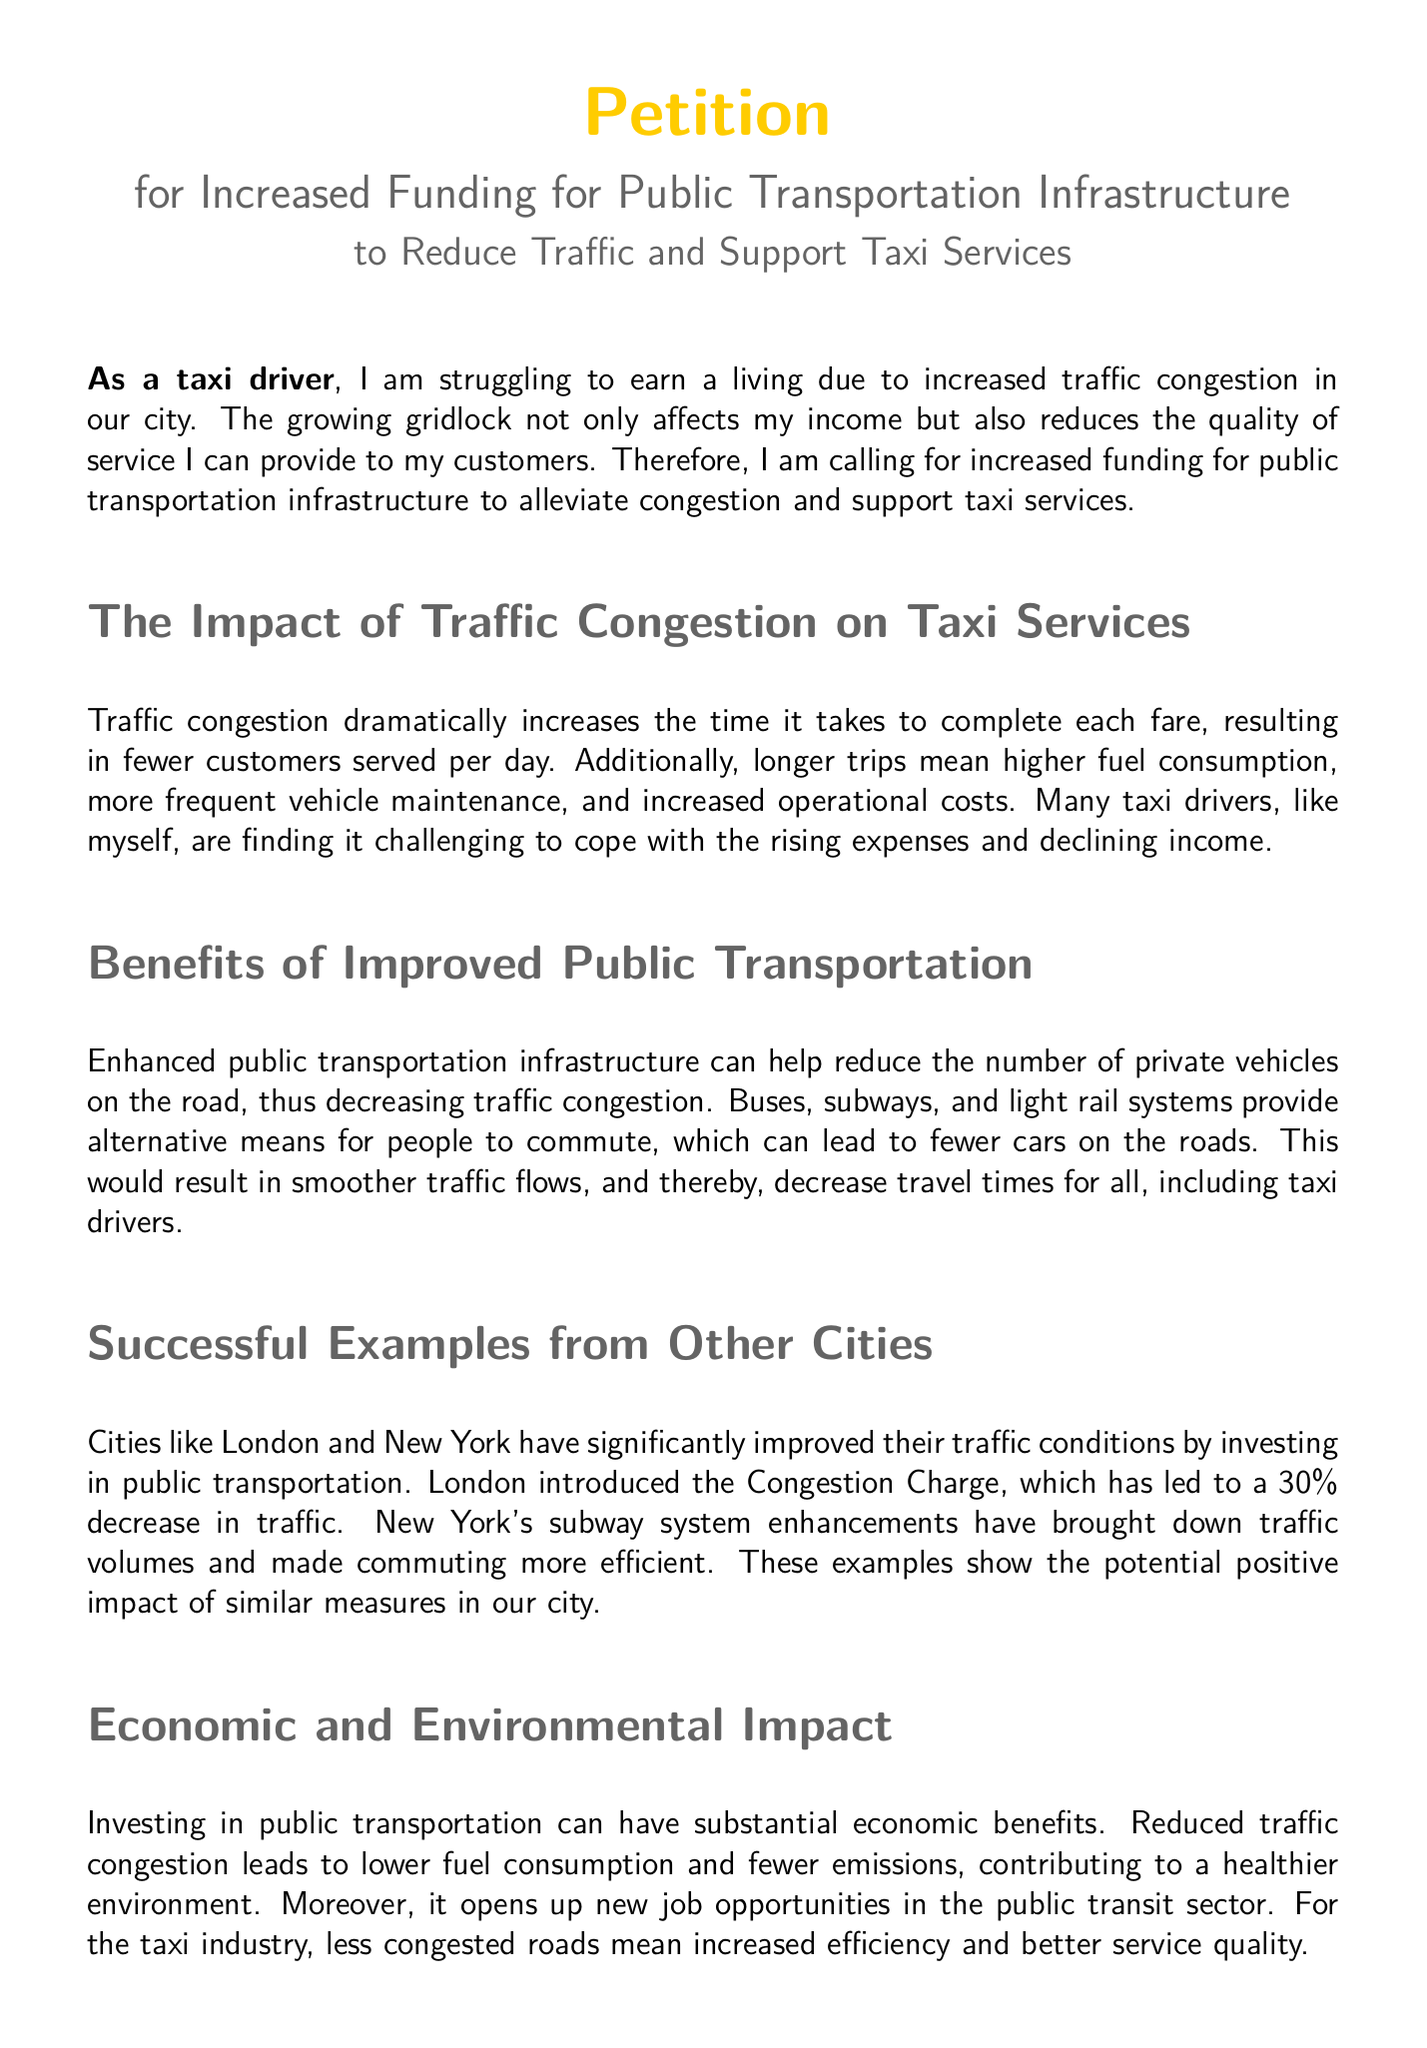What is the main purpose of the petition? The main purpose is to call for increased funding for public transportation infrastructure to alleviate congestion and support taxi services.
Answer: Increased funding for public transportation infrastructure How does traffic congestion affect taxi drivers? Traffic congestion increases the time it takes to complete each fare, resulting in fewer customers served per day and higher operational costs.
Answer: It increases fare time and operational costs What percentage decrease in traffic did London's Congestion Charge achieve? The document states that London's Congestion Charge led to a 30% decrease in traffic.
Answer: 30% What are the potential economic benefits of investing in public transportation? Investing in public transportation can lead to lower fuel consumption, fewer emissions, and new job opportunities in the public transit sector.
Answer: Economic benefits include lower fuel consumption and new job opportunities Who is urged to allocate increased funding? The petition urges the local government and city council to allocate increased funding for public transportation infrastructure.
Answer: Local government and city council What is mentioned as a successful example of improved traffic conditions? The document mentions London and New York as successful examples of cities that improved traffic conditions through public transportation investment.
Answer: London and New York What does the signature line in the document indicate? The signature line is for individuals to sign and date the petition, indicating their support.
Answer: It indicates support for the petition How does improved public transportation benefit taxi services? Improved public transportation decreases the number of private vehicles on the road, leading to smoother traffic flows and decreased travel times for taxi drivers.
Answer: It decreases private vehicles and improves traffic flow What color is used for the petition's title? The color used for the petition's title is taxiyellow.
Answer: Taxiyellow 